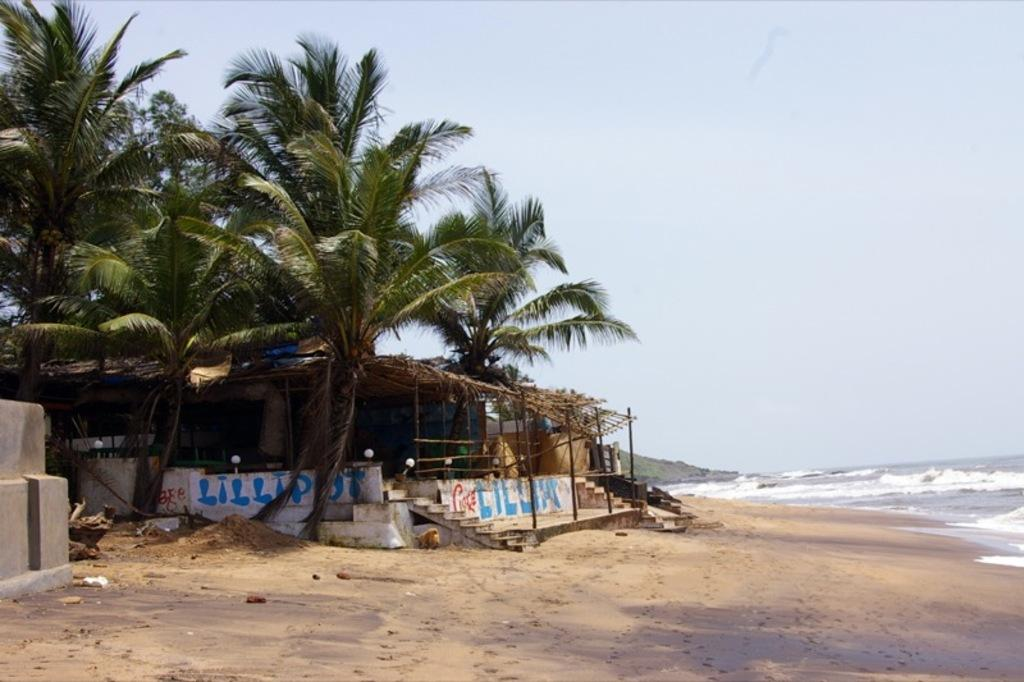What type of location is depicted in the image? There is a beach in the image. What structure can be seen in front of the beach? There is a hut in front of the beach. What type of vegetation is present around the beach? There are coconut trees around the beach. How many geese are visible on the beach in the image? There are no geese present in the image. What type of pin can be seen holding the hut together in the image? There is no pin visible in the image, and the hut's construction is not described in the provided facts. 